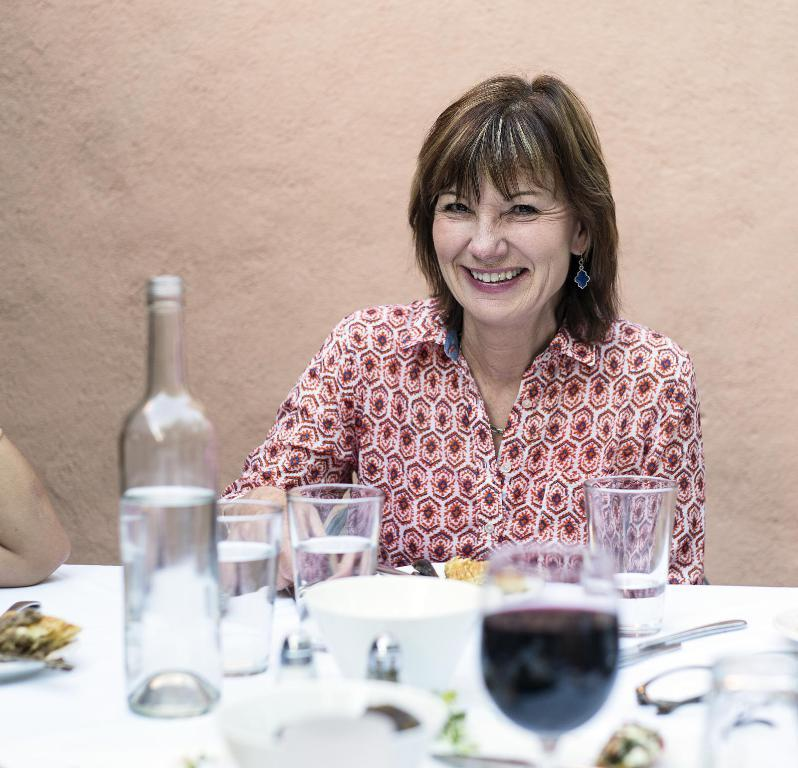What piece of furniture is present in the image? There is a table in the image. What items can be seen on the table? There is a bottle, glasses, a bowl, a cup, a spoon, and a fork on the table. What is the woman near the table doing? The woman is sitting near the table. What is the woman's facial expression? The woman is smiling. What type of volleyball game is happening in the background of the image? There is no volleyball game present in the image. How many blocks away is the downtown area from the location of the image? The location of the image does not provide information about the distance to the downtown area. 